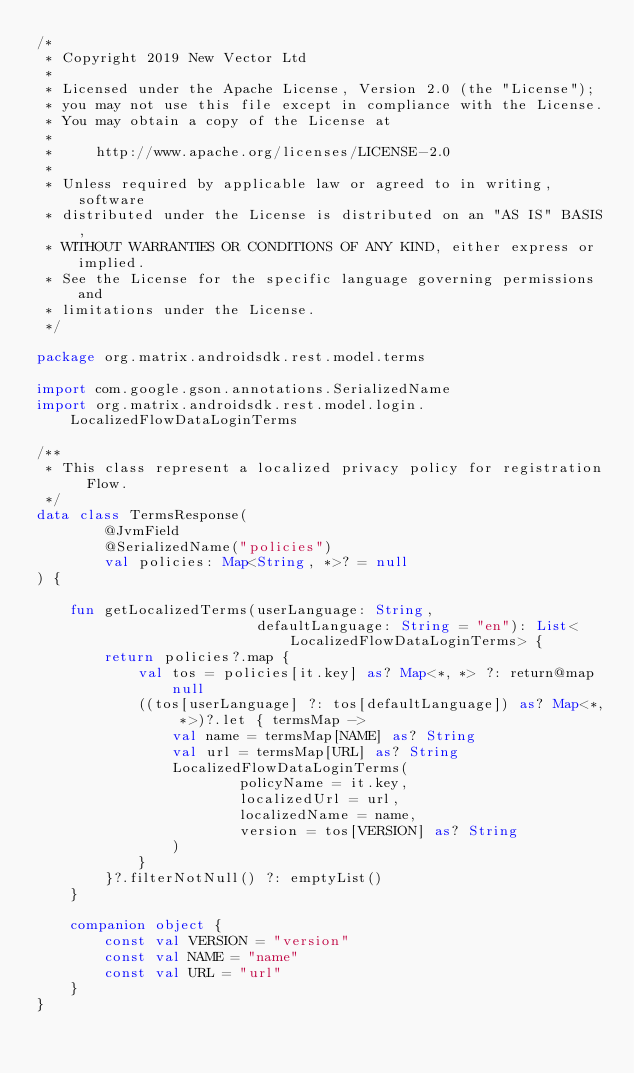<code> <loc_0><loc_0><loc_500><loc_500><_Kotlin_>/*
 * Copyright 2019 New Vector Ltd
 *
 * Licensed under the Apache License, Version 2.0 (the "License");
 * you may not use this file except in compliance with the License.
 * You may obtain a copy of the License at
 *
 *     http://www.apache.org/licenses/LICENSE-2.0
 *
 * Unless required by applicable law or agreed to in writing, software
 * distributed under the License is distributed on an "AS IS" BASIS,
 * WITHOUT WARRANTIES OR CONDITIONS OF ANY KIND, either express or implied.
 * See the License for the specific language governing permissions and
 * limitations under the License.
 */

package org.matrix.androidsdk.rest.model.terms

import com.google.gson.annotations.SerializedName
import org.matrix.androidsdk.rest.model.login.LocalizedFlowDataLoginTerms

/**
 * This class represent a localized privacy policy for registration Flow.
 */
data class TermsResponse(
        @JvmField
        @SerializedName("policies")
        val policies: Map<String, *>? = null
) {

    fun getLocalizedTerms(userLanguage: String,
                          defaultLanguage: String = "en"): List<LocalizedFlowDataLoginTerms> {
        return policies?.map {
            val tos = policies[it.key] as? Map<*, *> ?: return@map null
            ((tos[userLanguage] ?: tos[defaultLanguage]) as? Map<*, *>)?.let { termsMap ->
                val name = termsMap[NAME] as? String
                val url = termsMap[URL] as? String
                LocalizedFlowDataLoginTerms(
                        policyName = it.key,
                        localizedUrl = url,
                        localizedName = name,
                        version = tos[VERSION] as? String
                )
            }
        }?.filterNotNull() ?: emptyList()
    }

    companion object {
        const val VERSION = "version"
        const val NAME = "name"
        const val URL = "url"
    }
}

</code> 